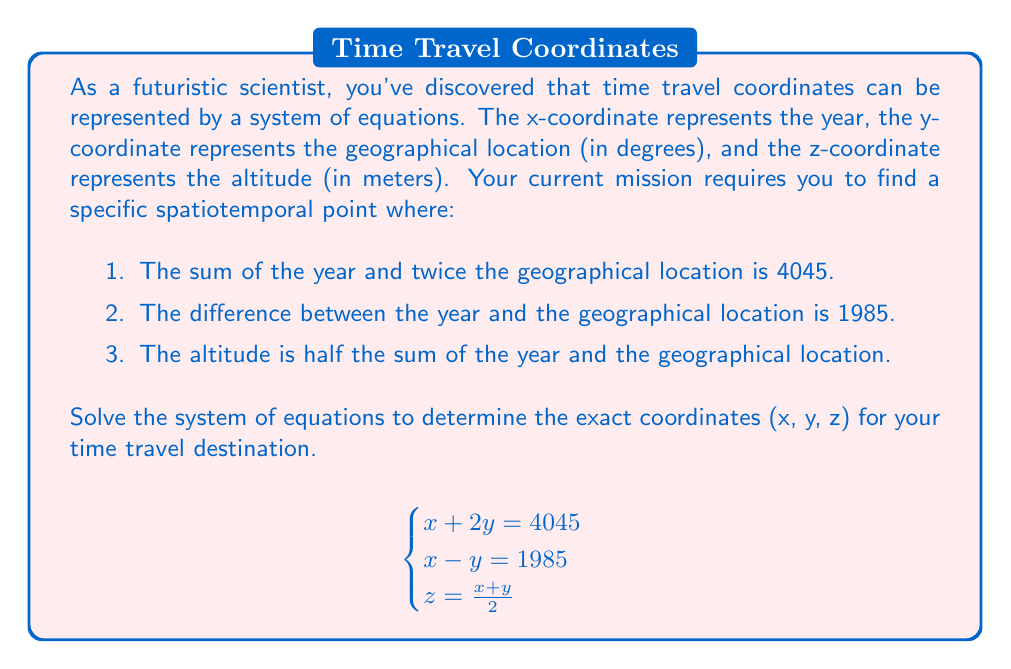Show me your answer to this math problem. Let's solve this system of equations step by step:

1) From the first two equations, we have:
   $$x + 2y = 4045 \quad (1)$$
   $$x - y = 1985 \quad (2)$$

2) Add equations (1) and (2):
   $$(x + 2y) + (x - y) = 4045 + 1985$$
   $$2x + y = 6030$$

3) Divide both sides by 2:
   $$x + \frac{y}{2} = 3015 \quad (3)$$

4) Now, subtract equation (2) from equation (3):
   $$(x + \frac{y}{2}) - (x - y) = 3015 - 1985$$
   $$\frac{3y}{2} = 1030$$

5) Multiply both sides by 2/3:
   $$y = \frac{2060}{3} \approx 686.67$$

6) Substitute this value of y into equation (2):
   $$x - 686.67 = 1985$$
   $$x = 2671.67$$

7) Now we have x and y, we can find z using the third equation:
   $$z = \frac{x + y}{2} = \frac{2671.67 + 686.67}{2} = 1679.17$$

8) Rounding to two decimal places for precision:
   x = 2671.67 (year)
   y = 686.67 (geographical location in degrees)
   z = 1679.17 (altitude in meters)
Answer: (2671.67, 686.67, 1679.17) 